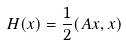Convert formula to latex. <formula><loc_0><loc_0><loc_500><loc_500>H ( x ) = \frac { 1 } { 2 } ( A x , x )</formula> 